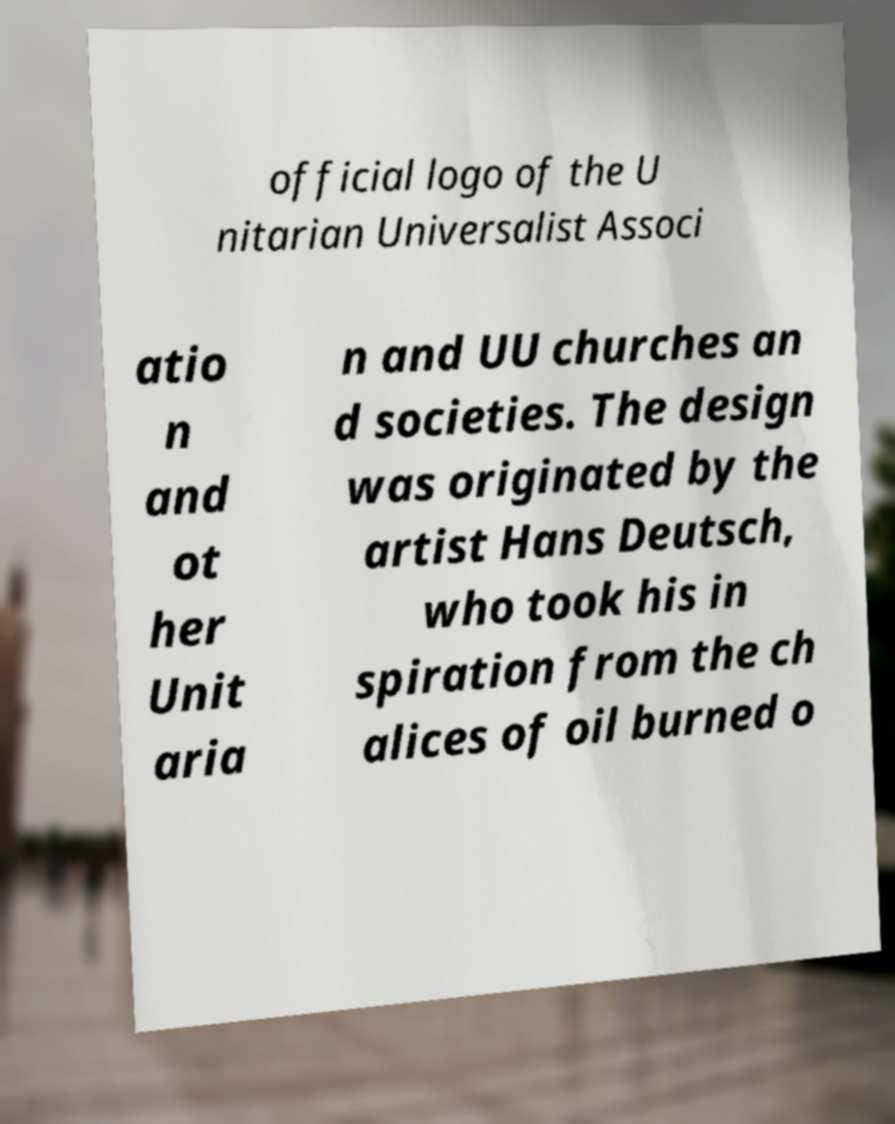Could you assist in decoding the text presented in this image and type it out clearly? official logo of the U nitarian Universalist Associ atio n and ot her Unit aria n and UU churches an d societies. The design was originated by the artist Hans Deutsch, who took his in spiration from the ch alices of oil burned o 